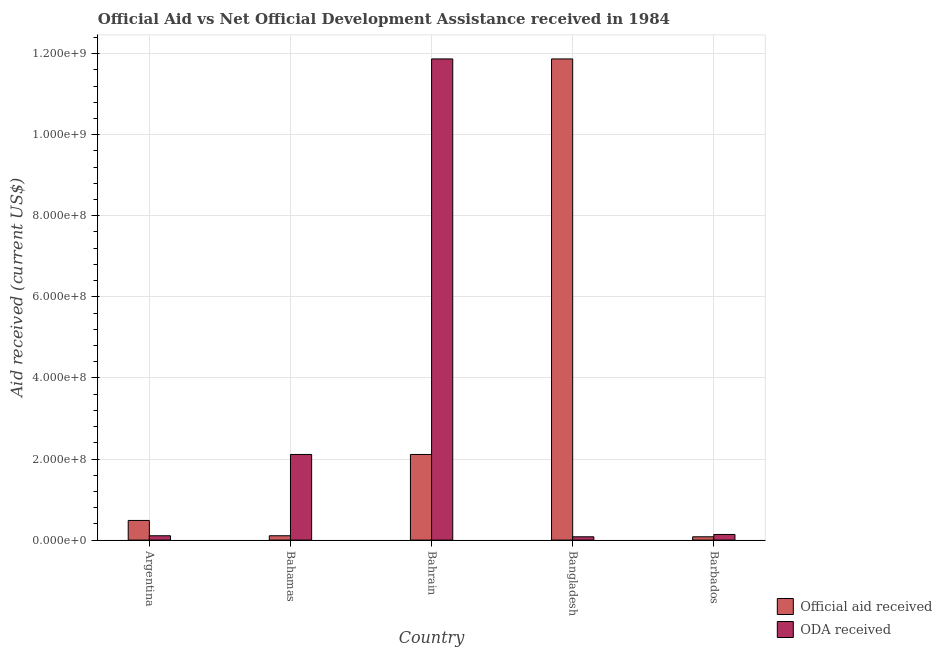How many different coloured bars are there?
Your response must be concise. 2. How many groups of bars are there?
Provide a succinct answer. 5. Are the number of bars per tick equal to the number of legend labels?
Ensure brevity in your answer.  Yes. Are the number of bars on each tick of the X-axis equal?
Provide a short and direct response. Yes. How many bars are there on the 5th tick from the left?
Make the answer very short. 2. How many bars are there on the 1st tick from the right?
Give a very brief answer. 2. What is the official aid received in Bahrain?
Ensure brevity in your answer.  2.11e+08. Across all countries, what is the maximum official aid received?
Keep it short and to the point. 1.19e+09. Across all countries, what is the minimum official aid received?
Keep it short and to the point. 8.15e+06. In which country was the oda received minimum?
Keep it short and to the point. Bangladesh. What is the total oda received in the graph?
Make the answer very short. 1.43e+09. What is the difference between the official aid received in Bahamas and that in Bahrain?
Offer a very short reply. -2.01e+08. What is the difference between the oda received in Argentina and the official aid received in Bahamas?
Your answer should be compact. 0. What is the average official aid received per country?
Your answer should be compact. 2.93e+08. What is the difference between the oda received and official aid received in Bangladesh?
Your answer should be compact. -1.18e+09. In how many countries, is the oda received greater than 40000000 US$?
Keep it short and to the point. 2. What is the ratio of the official aid received in Argentina to that in Bahrain?
Make the answer very short. 0.23. Is the official aid received in Bahrain less than that in Barbados?
Make the answer very short. No. What is the difference between the highest and the second highest official aid received?
Your answer should be very brief. 9.76e+08. What is the difference between the highest and the lowest official aid received?
Make the answer very short. 1.18e+09. Is the sum of the oda received in Argentina and Bahamas greater than the maximum official aid received across all countries?
Offer a terse response. No. What does the 2nd bar from the left in Barbados represents?
Your answer should be compact. ODA received. What does the 1st bar from the right in Barbados represents?
Offer a terse response. ODA received. What is the difference between two consecutive major ticks on the Y-axis?
Your answer should be very brief. 2.00e+08. Are the values on the major ticks of Y-axis written in scientific E-notation?
Your response must be concise. Yes. Does the graph contain grids?
Ensure brevity in your answer.  Yes. How many legend labels are there?
Your response must be concise. 2. How are the legend labels stacked?
Offer a very short reply. Vertical. What is the title of the graph?
Your response must be concise. Official Aid vs Net Official Development Assistance received in 1984 . Does "Non-solid fuel" appear as one of the legend labels in the graph?
Make the answer very short. No. What is the label or title of the X-axis?
Offer a terse response. Country. What is the label or title of the Y-axis?
Make the answer very short. Aid received (current US$). What is the Aid received (current US$) in Official aid received in Argentina?
Keep it short and to the point. 4.85e+07. What is the Aid received (current US$) in ODA received in Argentina?
Make the answer very short. 1.07e+07. What is the Aid received (current US$) of Official aid received in Bahamas?
Make the answer very short. 1.07e+07. What is the Aid received (current US$) of ODA received in Bahamas?
Offer a very short reply. 2.11e+08. What is the Aid received (current US$) of Official aid received in Bahrain?
Give a very brief answer. 2.11e+08. What is the Aid received (current US$) of ODA received in Bahrain?
Make the answer very short. 1.19e+09. What is the Aid received (current US$) in Official aid received in Bangladesh?
Provide a short and direct response. 1.19e+09. What is the Aid received (current US$) in ODA received in Bangladesh?
Provide a short and direct response. 8.15e+06. What is the Aid received (current US$) of Official aid received in Barbados?
Your response must be concise. 8.15e+06. What is the Aid received (current US$) of ODA received in Barbados?
Provide a succinct answer. 1.39e+07. Across all countries, what is the maximum Aid received (current US$) of Official aid received?
Your response must be concise. 1.19e+09. Across all countries, what is the maximum Aid received (current US$) in ODA received?
Ensure brevity in your answer.  1.19e+09. Across all countries, what is the minimum Aid received (current US$) in Official aid received?
Offer a terse response. 8.15e+06. Across all countries, what is the minimum Aid received (current US$) of ODA received?
Give a very brief answer. 8.15e+06. What is the total Aid received (current US$) of Official aid received in the graph?
Your answer should be compact. 1.47e+09. What is the total Aid received (current US$) of ODA received in the graph?
Give a very brief answer. 1.43e+09. What is the difference between the Aid received (current US$) of Official aid received in Argentina and that in Bahamas?
Offer a terse response. 3.78e+07. What is the difference between the Aid received (current US$) in ODA received in Argentina and that in Bahamas?
Your answer should be compact. -2.01e+08. What is the difference between the Aid received (current US$) in Official aid received in Argentina and that in Bahrain?
Give a very brief answer. -1.63e+08. What is the difference between the Aid received (current US$) in ODA received in Argentina and that in Bahrain?
Offer a terse response. -1.18e+09. What is the difference between the Aid received (current US$) in Official aid received in Argentina and that in Bangladesh?
Offer a very short reply. -1.14e+09. What is the difference between the Aid received (current US$) of ODA received in Argentina and that in Bangladesh?
Your answer should be compact. 2.55e+06. What is the difference between the Aid received (current US$) in Official aid received in Argentina and that in Barbados?
Offer a very short reply. 4.03e+07. What is the difference between the Aid received (current US$) of ODA received in Argentina and that in Barbados?
Keep it short and to the point. -3.20e+06. What is the difference between the Aid received (current US$) of Official aid received in Bahamas and that in Bahrain?
Offer a very short reply. -2.01e+08. What is the difference between the Aid received (current US$) in ODA received in Bahamas and that in Bahrain?
Your answer should be very brief. -9.76e+08. What is the difference between the Aid received (current US$) of Official aid received in Bahamas and that in Bangladesh?
Offer a terse response. -1.18e+09. What is the difference between the Aid received (current US$) of ODA received in Bahamas and that in Bangladesh?
Your response must be concise. 2.03e+08. What is the difference between the Aid received (current US$) in Official aid received in Bahamas and that in Barbados?
Ensure brevity in your answer.  2.55e+06. What is the difference between the Aid received (current US$) of ODA received in Bahamas and that in Barbados?
Provide a short and direct response. 1.97e+08. What is the difference between the Aid received (current US$) of Official aid received in Bahrain and that in Bangladesh?
Ensure brevity in your answer.  -9.76e+08. What is the difference between the Aid received (current US$) in ODA received in Bahrain and that in Bangladesh?
Your answer should be very brief. 1.18e+09. What is the difference between the Aid received (current US$) in Official aid received in Bahrain and that in Barbados?
Ensure brevity in your answer.  2.03e+08. What is the difference between the Aid received (current US$) of ODA received in Bahrain and that in Barbados?
Offer a terse response. 1.17e+09. What is the difference between the Aid received (current US$) in Official aid received in Bangladesh and that in Barbados?
Your response must be concise. 1.18e+09. What is the difference between the Aid received (current US$) of ODA received in Bangladesh and that in Barbados?
Make the answer very short. -5.75e+06. What is the difference between the Aid received (current US$) of Official aid received in Argentina and the Aid received (current US$) of ODA received in Bahamas?
Your answer should be very brief. -1.63e+08. What is the difference between the Aid received (current US$) in Official aid received in Argentina and the Aid received (current US$) in ODA received in Bahrain?
Offer a terse response. -1.14e+09. What is the difference between the Aid received (current US$) of Official aid received in Argentina and the Aid received (current US$) of ODA received in Bangladesh?
Your response must be concise. 4.03e+07. What is the difference between the Aid received (current US$) of Official aid received in Argentina and the Aid received (current US$) of ODA received in Barbados?
Offer a terse response. 3.46e+07. What is the difference between the Aid received (current US$) of Official aid received in Bahamas and the Aid received (current US$) of ODA received in Bahrain?
Offer a very short reply. -1.18e+09. What is the difference between the Aid received (current US$) in Official aid received in Bahamas and the Aid received (current US$) in ODA received in Bangladesh?
Give a very brief answer. 2.55e+06. What is the difference between the Aid received (current US$) of Official aid received in Bahamas and the Aid received (current US$) of ODA received in Barbados?
Make the answer very short. -3.20e+06. What is the difference between the Aid received (current US$) in Official aid received in Bahrain and the Aid received (current US$) in ODA received in Bangladesh?
Provide a short and direct response. 2.03e+08. What is the difference between the Aid received (current US$) in Official aid received in Bahrain and the Aid received (current US$) in ODA received in Barbados?
Offer a very short reply. 1.97e+08. What is the difference between the Aid received (current US$) of Official aid received in Bangladesh and the Aid received (current US$) of ODA received in Barbados?
Offer a very short reply. 1.17e+09. What is the average Aid received (current US$) in Official aid received per country?
Your response must be concise. 2.93e+08. What is the average Aid received (current US$) of ODA received per country?
Keep it short and to the point. 2.86e+08. What is the difference between the Aid received (current US$) of Official aid received and Aid received (current US$) of ODA received in Argentina?
Offer a very short reply. 3.78e+07. What is the difference between the Aid received (current US$) in Official aid received and Aid received (current US$) in ODA received in Bahamas?
Ensure brevity in your answer.  -2.01e+08. What is the difference between the Aid received (current US$) in Official aid received and Aid received (current US$) in ODA received in Bahrain?
Provide a short and direct response. -9.76e+08. What is the difference between the Aid received (current US$) of Official aid received and Aid received (current US$) of ODA received in Bangladesh?
Give a very brief answer. 1.18e+09. What is the difference between the Aid received (current US$) of Official aid received and Aid received (current US$) of ODA received in Barbados?
Give a very brief answer. -5.75e+06. What is the ratio of the Aid received (current US$) in Official aid received in Argentina to that in Bahamas?
Offer a terse response. 4.53. What is the ratio of the Aid received (current US$) in ODA received in Argentina to that in Bahamas?
Give a very brief answer. 0.05. What is the ratio of the Aid received (current US$) in Official aid received in Argentina to that in Bahrain?
Provide a short and direct response. 0.23. What is the ratio of the Aid received (current US$) in ODA received in Argentina to that in Bahrain?
Your answer should be very brief. 0.01. What is the ratio of the Aid received (current US$) of Official aid received in Argentina to that in Bangladesh?
Give a very brief answer. 0.04. What is the ratio of the Aid received (current US$) of ODA received in Argentina to that in Bangladesh?
Give a very brief answer. 1.31. What is the ratio of the Aid received (current US$) in Official aid received in Argentina to that in Barbados?
Your answer should be very brief. 5.95. What is the ratio of the Aid received (current US$) in ODA received in Argentina to that in Barbados?
Your response must be concise. 0.77. What is the ratio of the Aid received (current US$) of Official aid received in Bahamas to that in Bahrain?
Ensure brevity in your answer.  0.05. What is the ratio of the Aid received (current US$) of ODA received in Bahamas to that in Bahrain?
Offer a terse response. 0.18. What is the ratio of the Aid received (current US$) of Official aid received in Bahamas to that in Bangladesh?
Offer a very short reply. 0.01. What is the ratio of the Aid received (current US$) in ODA received in Bahamas to that in Bangladesh?
Your answer should be very brief. 25.92. What is the ratio of the Aid received (current US$) in Official aid received in Bahamas to that in Barbados?
Ensure brevity in your answer.  1.31. What is the ratio of the Aid received (current US$) of ODA received in Bahamas to that in Barbados?
Provide a succinct answer. 15.2. What is the ratio of the Aid received (current US$) of Official aid received in Bahrain to that in Bangladesh?
Give a very brief answer. 0.18. What is the ratio of the Aid received (current US$) of ODA received in Bahrain to that in Bangladesh?
Provide a succinct answer. 145.62. What is the ratio of the Aid received (current US$) in Official aid received in Bahrain to that in Barbados?
Your answer should be very brief. 25.92. What is the ratio of the Aid received (current US$) in ODA received in Bahrain to that in Barbados?
Your response must be concise. 85.38. What is the ratio of the Aid received (current US$) in Official aid received in Bangladesh to that in Barbados?
Keep it short and to the point. 145.62. What is the ratio of the Aid received (current US$) in ODA received in Bangladesh to that in Barbados?
Offer a terse response. 0.59. What is the difference between the highest and the second highest Aid received (current US$) in Official aid received?
Provide a succinct answer. 9.76e+08. What is the difference between the highest and the second highest Aid received (current US$) of ODA received?
Ensure brevity in your answer.  9.76e+08. What is the difference between the highest and the lowest Aid received (current US$) of Official aid received?
Offer a very short reply. 1.18e+09. What is the difference between the highest and the lowest Aid received (current US$) of ODA received?
Keep it short and to the point. 1.18e+09. 